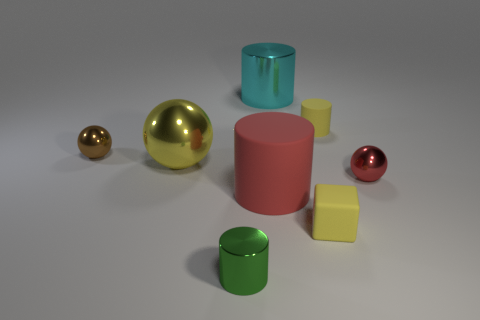There is a small thing that is the same color as the block; what material is it?
Offer a very short reply. Rubber. There is a small matte thing that is the same shape as the cyan metal object; what color is it?
Offer a terse response. Yellow. Is there any other thing that is the same shape as the large yellow thing?
Provide a short and direct response. Yes. Is the number of red metal objects greater than the number of shiny things?
Make the answer very short. No. How many other objects are the same material as the green cylinder?
Your response must be concise. 4. What is the shape of the small metallic thing on the right side of the yellow rubber object that is in front of the yellow metal thing that is behind the small red shiny ball?
Offer a terse response. Sphere. Are there fewer blocks right of the small matte cylinder than tiny green things that are behind the red shiny object?
Provide a succinct answer. No. Are there any other metallic blocks that have the same color as the block?
Your answer should be compact. No. Does the green thing have the same material as the large cyan object that is behind the big matte object?
Give a very brief answer. Yes. Are there any cyan shiny cylinders that are to the right of the metallic object on the right side of the big cyan object?
Your response must be concise. No. 